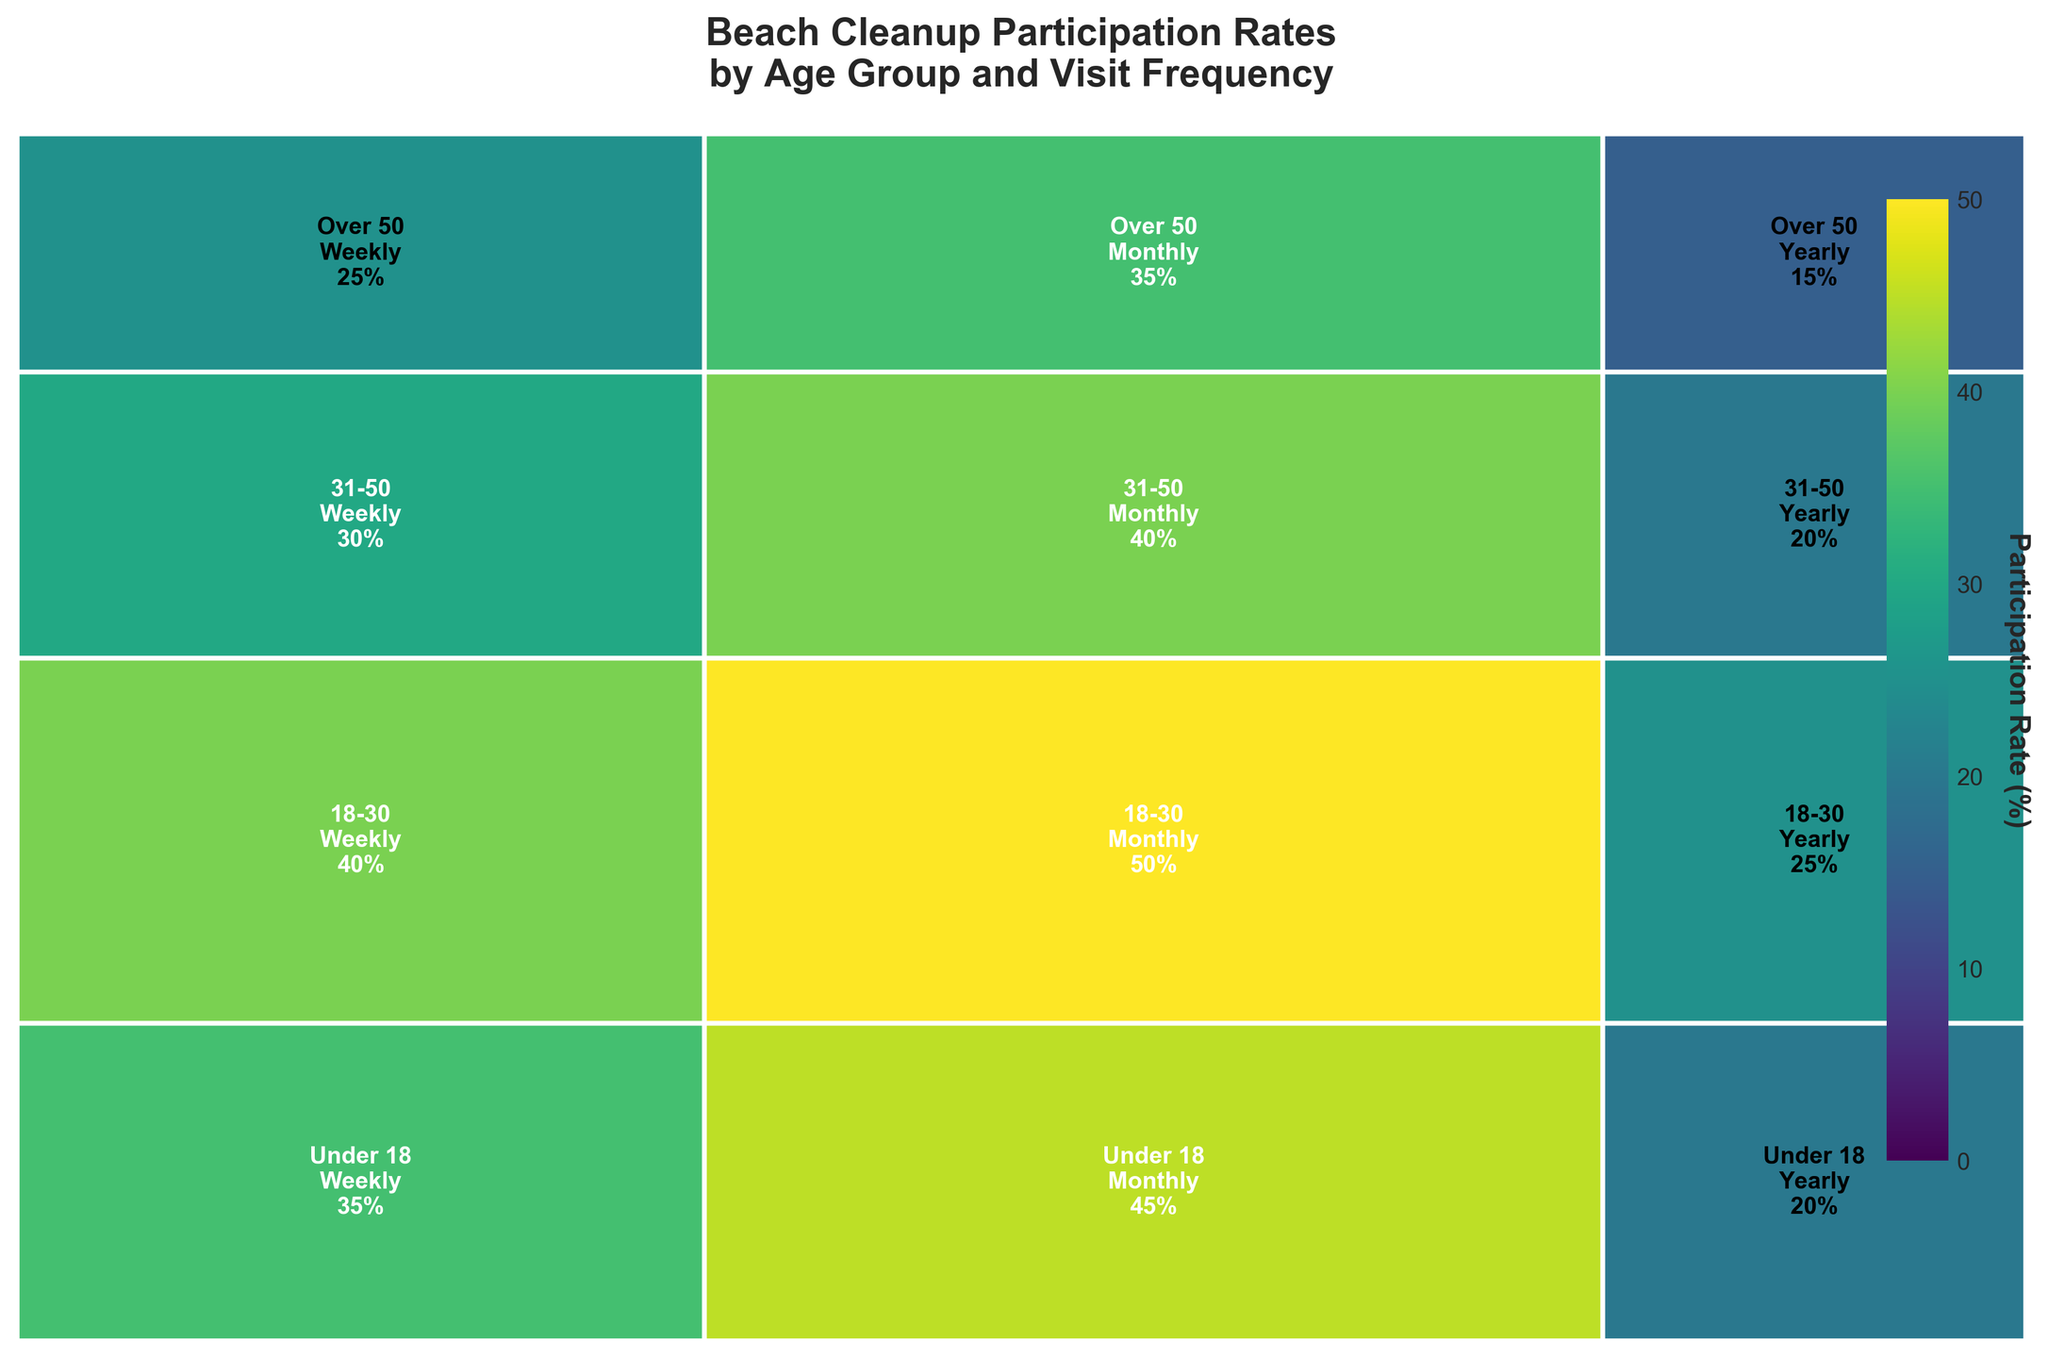Which age group has the highest participation rate for weekly visits? Look for the highest percentage labeled within the "Weekly" column rectangles. The rectangle for the "31-50" age group shows 50%, which is the highest.
Answer: 31-50 Overall, which age group participates the least in beach cleanups? Sum the percentages of each age group across all visit frequencies. "Under 18" sums to 75%, which is the lowest.
Answer: Under 18 What is the average participation rate for the "18-30" age group across all visit frequencies? Sum the percentages for "18-30" (45% + 35% + 20%) and divide by 3. This results in (45 + 35 + 20) / 3 = 33.3%.
Answer: 33.3% Compare the participation rates for "Over 50" in weekly and yearly visits. Which is higher? Find the rectangles for "Over 50" in "Weekly" (40%) and "Yearly" (20%) columns. "Weekly" (40%) is higher.
Answer: Weekly Which visit frequency shows the highest participation rate within the "Under 18" age group? Compare the percentages in the "Under 18" row: Weekly (35%), Monthly (25%), and Yearly (15%). "Weekly" has the highest at 35%.
Answer: Weekly How does the "Monthly" participation rate for "31-50" compare against "18-30"? Look at the numbers for "31-50" in the "Monthly" column (40%) and "18-30" in the "Monthly" column (35%). 40% is greater than 35%.
Answer: 31-50 What specific color range indicates the highest participation rates on the color bar? Locate the color bar on the right side; the highest participation rate (around 50%) is shown near the yellowish-green end of the gradient.
Answer: Yellowish-green Is the participation rate higher for "Monthly" or "Yearly" visits within the "Over 50" age group? Compare "Over 50" in "Monthly" (30%) and "Yearly" (20%) columns. 30% is higher than 20%.
Answer: Monthly What percentage of participants from the "Under 18" group visit the beach weekly? Find the percentage for "Under 18" in the "Weekly" column, which is 35%.
Answer: 35% Which age group has the highest overall participation rate regardless of visit frequency? Sum the participation rates for each age group: "31-50" has the highest total with 115%.
Answer: 31-50 